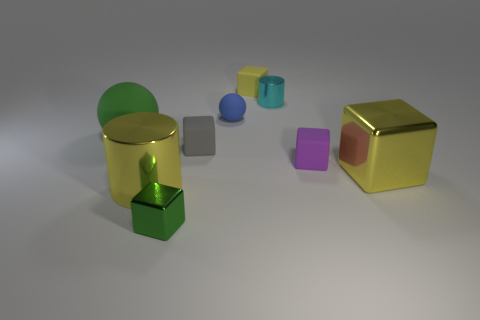There is a green ball; is it the same size as the yellow cube that is in front of the tiny cyan metal thing?
Offer a terse response. Yes. Are there more rubber blocks that are to the left of the yellow matte object than tiny gray shiny spheres?
Your response must be concise. Yes. How many green rubber objects have the same size as the gray block?
Offer a very short reply. 0. There is a matte sphere that is behind the large rubber sphere; does it have the same size as the shiny cylinder behind the tiny rubber ball?
Make the answer very short. Yes. Is the number of blue spheres that are behind the green sphere greater than the number of tiny gray blocks on the right side of the gray thing?
Your answer should be very brief. Yes. How many other large things have the same shape as the gray thing?
Your response must be concise. 1. There is a gray block that is the same size as the cyan thing; what is it made of?
Provide a succinct answer. Rubber. Are there any small yellow objects made of the same material as the small gray object?
Make the answer very short. Yes. Is the number of large yellow objects on the right side of the blue object less than the number of rubber objects?
Your answer should be compact. Yes. What is the material of the ball on the left side of the tiny metallic thing that is in front of the cyan cylinder?
Keep it short and to the point. Rubber. 